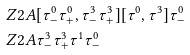<formula> <loc_0><loc_0><loc_500><loc_500>& Z 2 A [ \tau ^ { 0 } _ { - } \tau ^ { 0 } _ { + } , \tau ^ { 3 } _ { - } \tau ^ { 3 } _ { + } ] [ \tau ^ { 0 } , \tau ^ { 3 } ] \tau ^ { 0 } _ { - } \\ & Z 2 A \tau ^ { 3 } _ { - } \tau ^ { 3 } _ { + } \tau ^ { 1 } \tau ^ { 0 } _ { - } \\</formula> 